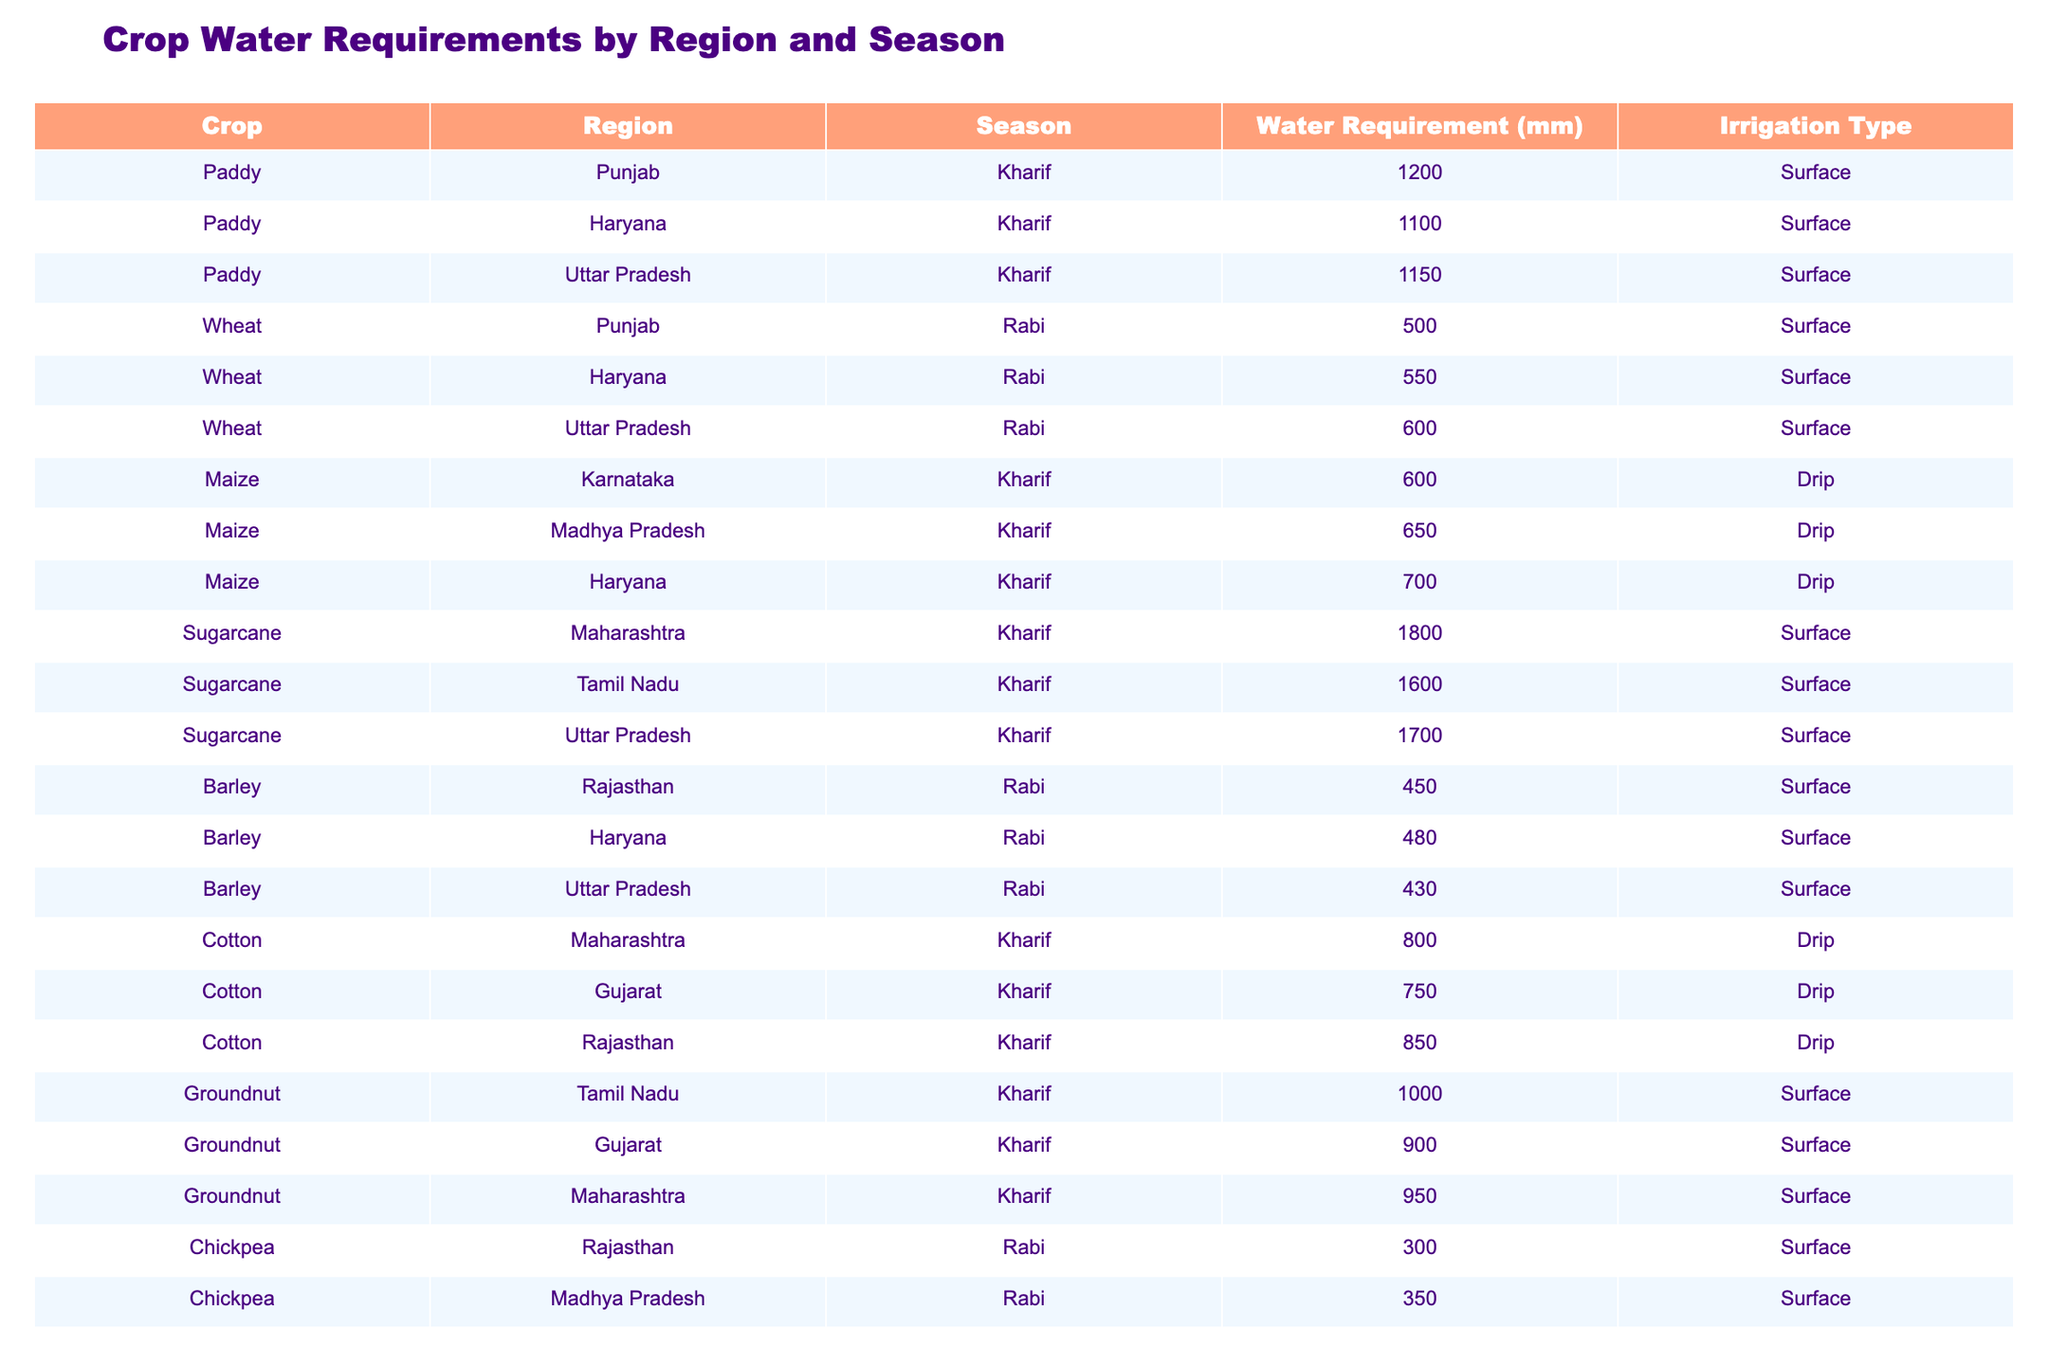What is the water requirement for sugarcane in Maharashtra during the Kharif season? The table shows that the water requirement for sugarcane in Maharashtra during the Kharif season is 1800 mm.
Answer: 1800 mm What is the average water requirement for wheat across all regions in the Rabi season? The water requirements for wheat in Rabi season are 500 mm (Punjab), 550 mm (Haryana), and 600 mm (Uttar Pradesh). The average is calculated as (500 + 550 + 600) / 3 = 550 mm.
Answer: 550 mm Is the water requirement for cotton higher in Rajasthan compared to Gujarat during the Kharif season? The table shows that the water requirement for cotton in Rajasthan is 850 mm, while in Gujarat it is 750 mm. Since 850 mm > 750 mm, the statement is true.
Answer: Yes What is the difference in water requirement between paddy in Haryana and Uttar Pradesh during the Kharif season? The water requirement for paddy in Haryana is 1100 mm and in Uttar Pradesh is 1150 mm. The difference is calculated as 1150 mm - 1100 mm = 50 mm.
Answer: 50 mm Which crop has the highest water requirement in the Kharif season among the listed crops? The highest water requirement in the Kharif season is for sugarcane in Maharashtra, which requires 1800 mm.
Answer: Sugarcane What is the total water requirement for maize across Karnataka and Madhya Pradesh in the Kharif season? The water requirements for maize are 600 mm (Karnataka) and 650 mm (Madhya Pradesh). The total is calculated as 600 mm + 650 mm = 1250 mm.
Answer: 1250 mm Is groundnut more water-intensive than sorghum in Tamil Nadu during the Kharif season? The water requirement for groundnut in Tamil Nadu is 1000 mm, while for sorghum it is 370 mm. Since 1000 mm > 370 mm, the statement is true.
Answer: Yes What is the median water requirement for chickpea in the Rabi season across the regions provided? The water requirements for chickpea in Rabi season are 300 mm (Rajasthan), 350 mm (Madhya Pradesh), and 320 mm (Uttar Pradesh). The median is the middle value when sorted (300, 320, 350), which is 320 mm.
Answer: 320 mm How does the water requirement for barley in Haryana compare to that in Uttar Pradesh during the Rabi season? The water requirement for barley in Haryana is 480 mm, while in Uttar Pradesh it is 430 mm. Since 480 mm > 430 mm, barley in Haryana requires more water.
Answer: More What crop has the lowest water requirement in the Rabi season based on the table? The lowest water requirement in the Rabi season is for chickpea in Rajasthan, with a requirement of 300 mm.
Answer: Chickpea 